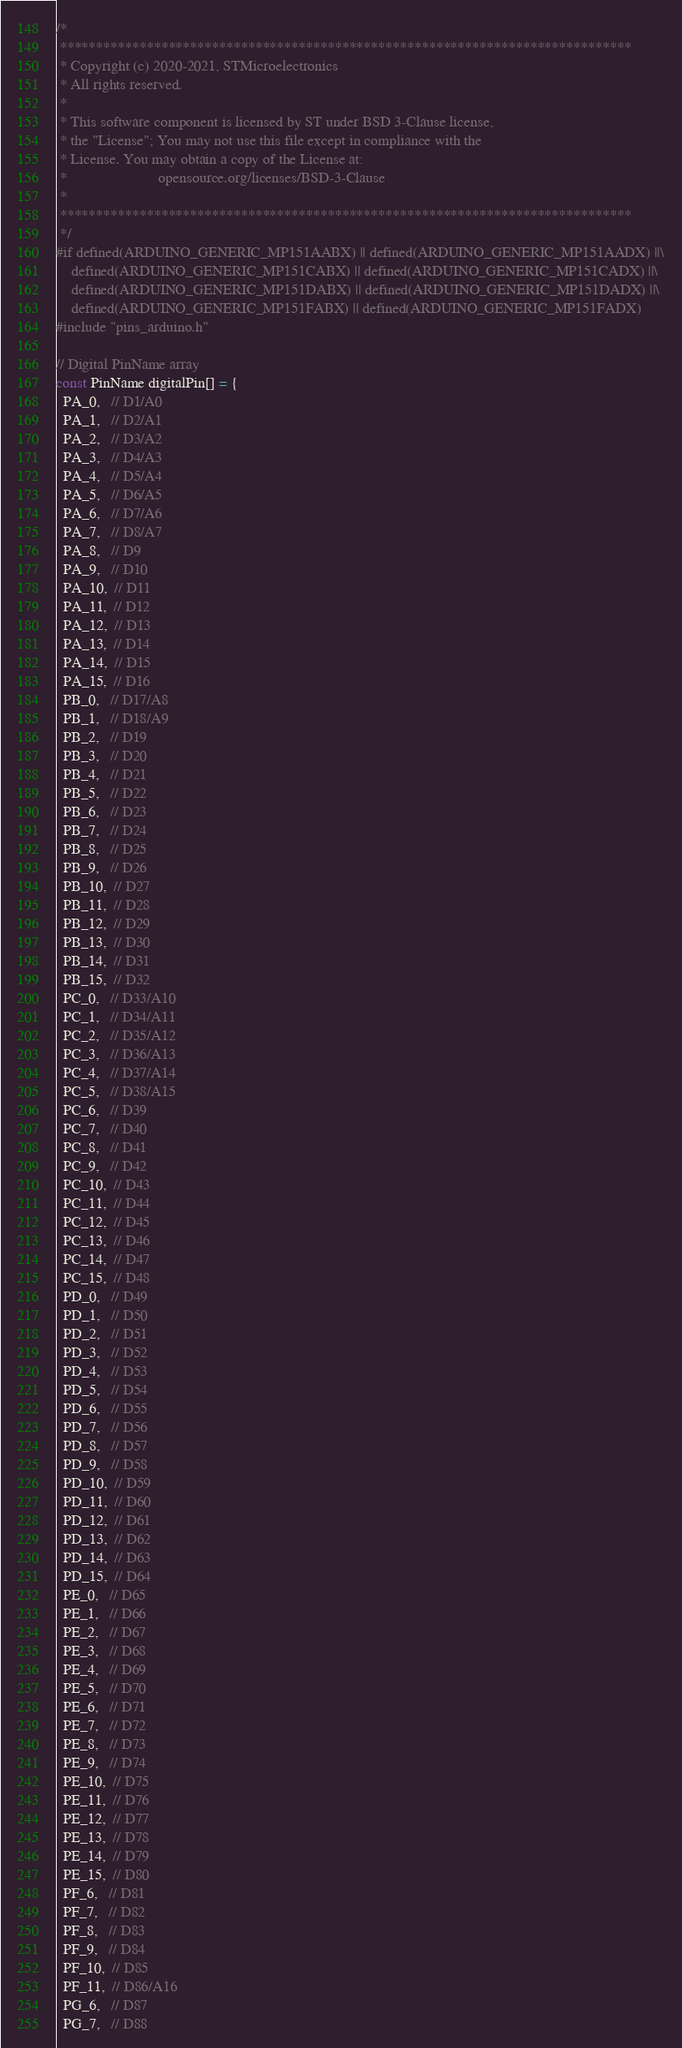<code> <loc_0><loc_0><loc_500><loc_500><_C++_>/*
 *******************************************************************************
 * Copyright (c) 2020-2021, STMicroelectronics
 * All rights reserved.
 *
 * This software component is licensed by ST under BSD 3-Clause license,
 * the "License"; You may not use this file except in compliance with the
 * License. You may obtain a copy of the License at:
 *                        opensource.org/licenses/BSD-3-Clause
 *
 *******************************************************************************
 */
#if defined(ARDUINO_GENERIC_MP151AABX) || defined(ARDUINO_GENERIC_MP151AADX) ||\
    defined(ARDUINO_GENERIC_MP151CABX) || defined(ARDUINO_GENERIC_MP151CADX) ||\
    defined(ARDUINO_GENERIC_MP151DABX) || defined(ARDUINO_GENERIC_MP151DADX) ||\
    defined(ARDUINO_GENERIC_MP151FABX) || defined(ARDUINO_GENERIC_MP151FADX)
#include "pins_arduino.h"

// Digital PinName array
const PinName digitalPin[] = {
  PA_0,   // D1/A0
  PA_1,   // D2/A1
  PA_2,   // D3/A2
  PA_3,   // D4/A3
  PA_4,   // D5/A4
  PA_5,   // D6/A5
  PA_6,   // D7/A6
  PA_7,   // D8/A7
  PA_8,   // D9
  PA_9,   // D10
  PA_10,  // D11
  PA_11,  // D12
  PA_12,  // D13
  PA_13,  // D14
  PA_14,  // D15
  PA_15,  // D16
  PB_0,   // D17/A8
  PB_1,   // D18/A9
  PB_2,   // D19
  PB_3,   // D20
  PB_4,   // D21
  PB_5,   // D22
  PB_6,   // D23
  PB_7,   // D24
  PB_8,   // D25
  PB_9,   // D26
  PB_10,  // D27
  PB_11,  // D28
  PB_12,  // D29
  PB_13,  // D30
  PB_14,  // D31
  PB_15,  // D32
  PC_0,   // D33/A10
  PC_1,   // D34/A11
  PC_2,   // D35/A12
  PC_3,   // D36/A13
  PC_4,   // D37/A14
  PC_5,   // D38/A15
  PC_6,   // D39
  PC_7,   // D40
  PC_8,   // D41
  PC_9,   // D42
  PC_10,  // D43
  PC_11,  // D44
  PC_12,  // D45
  PC_13,  // D46
  PC_14,  // D47
  PC_15,  // D48
  PD_0,   // D49
  PD_1,   // D50
  PD_2,   // D51
  PD_3,   // D52
  PD_4,   // D53
  PD_5,   // D54
  PD_6,   // D55
  PD_7,   // D56
  PD_8,   // D57
  PD_9,   // D58
  PD_10,  // D59
  PD_11,  // D60
  PD_12,  // D61
  PD_13,  // D62
  PD_14,  // D63
  PD_15,  // D64
  PE_0,   // D65
  PE_1,   // D66
  PE_2,   // D67
  PE_3,   // D68
  PE_4,   // D69
  PE_5,   // D70
  PE_6,   // D71
  PE_7,   // D72
  PE_8,   // D73
  PE_9,   // D74
  PE_10,  // D75
  PE_11,  // D76
  PE_12,  // D77
  PE_13,  // D78
  PE_14,  // D79
  PE_15,  // D80
  PF_6,   // D81
  PF_7,   // D82
  PF_8,   // D83
  PF_9,   // D84
  PF_10,  // D85
  PF_11,  // D86/A16
  PG_6,   // D87
  PG_7,   // D88</code> 